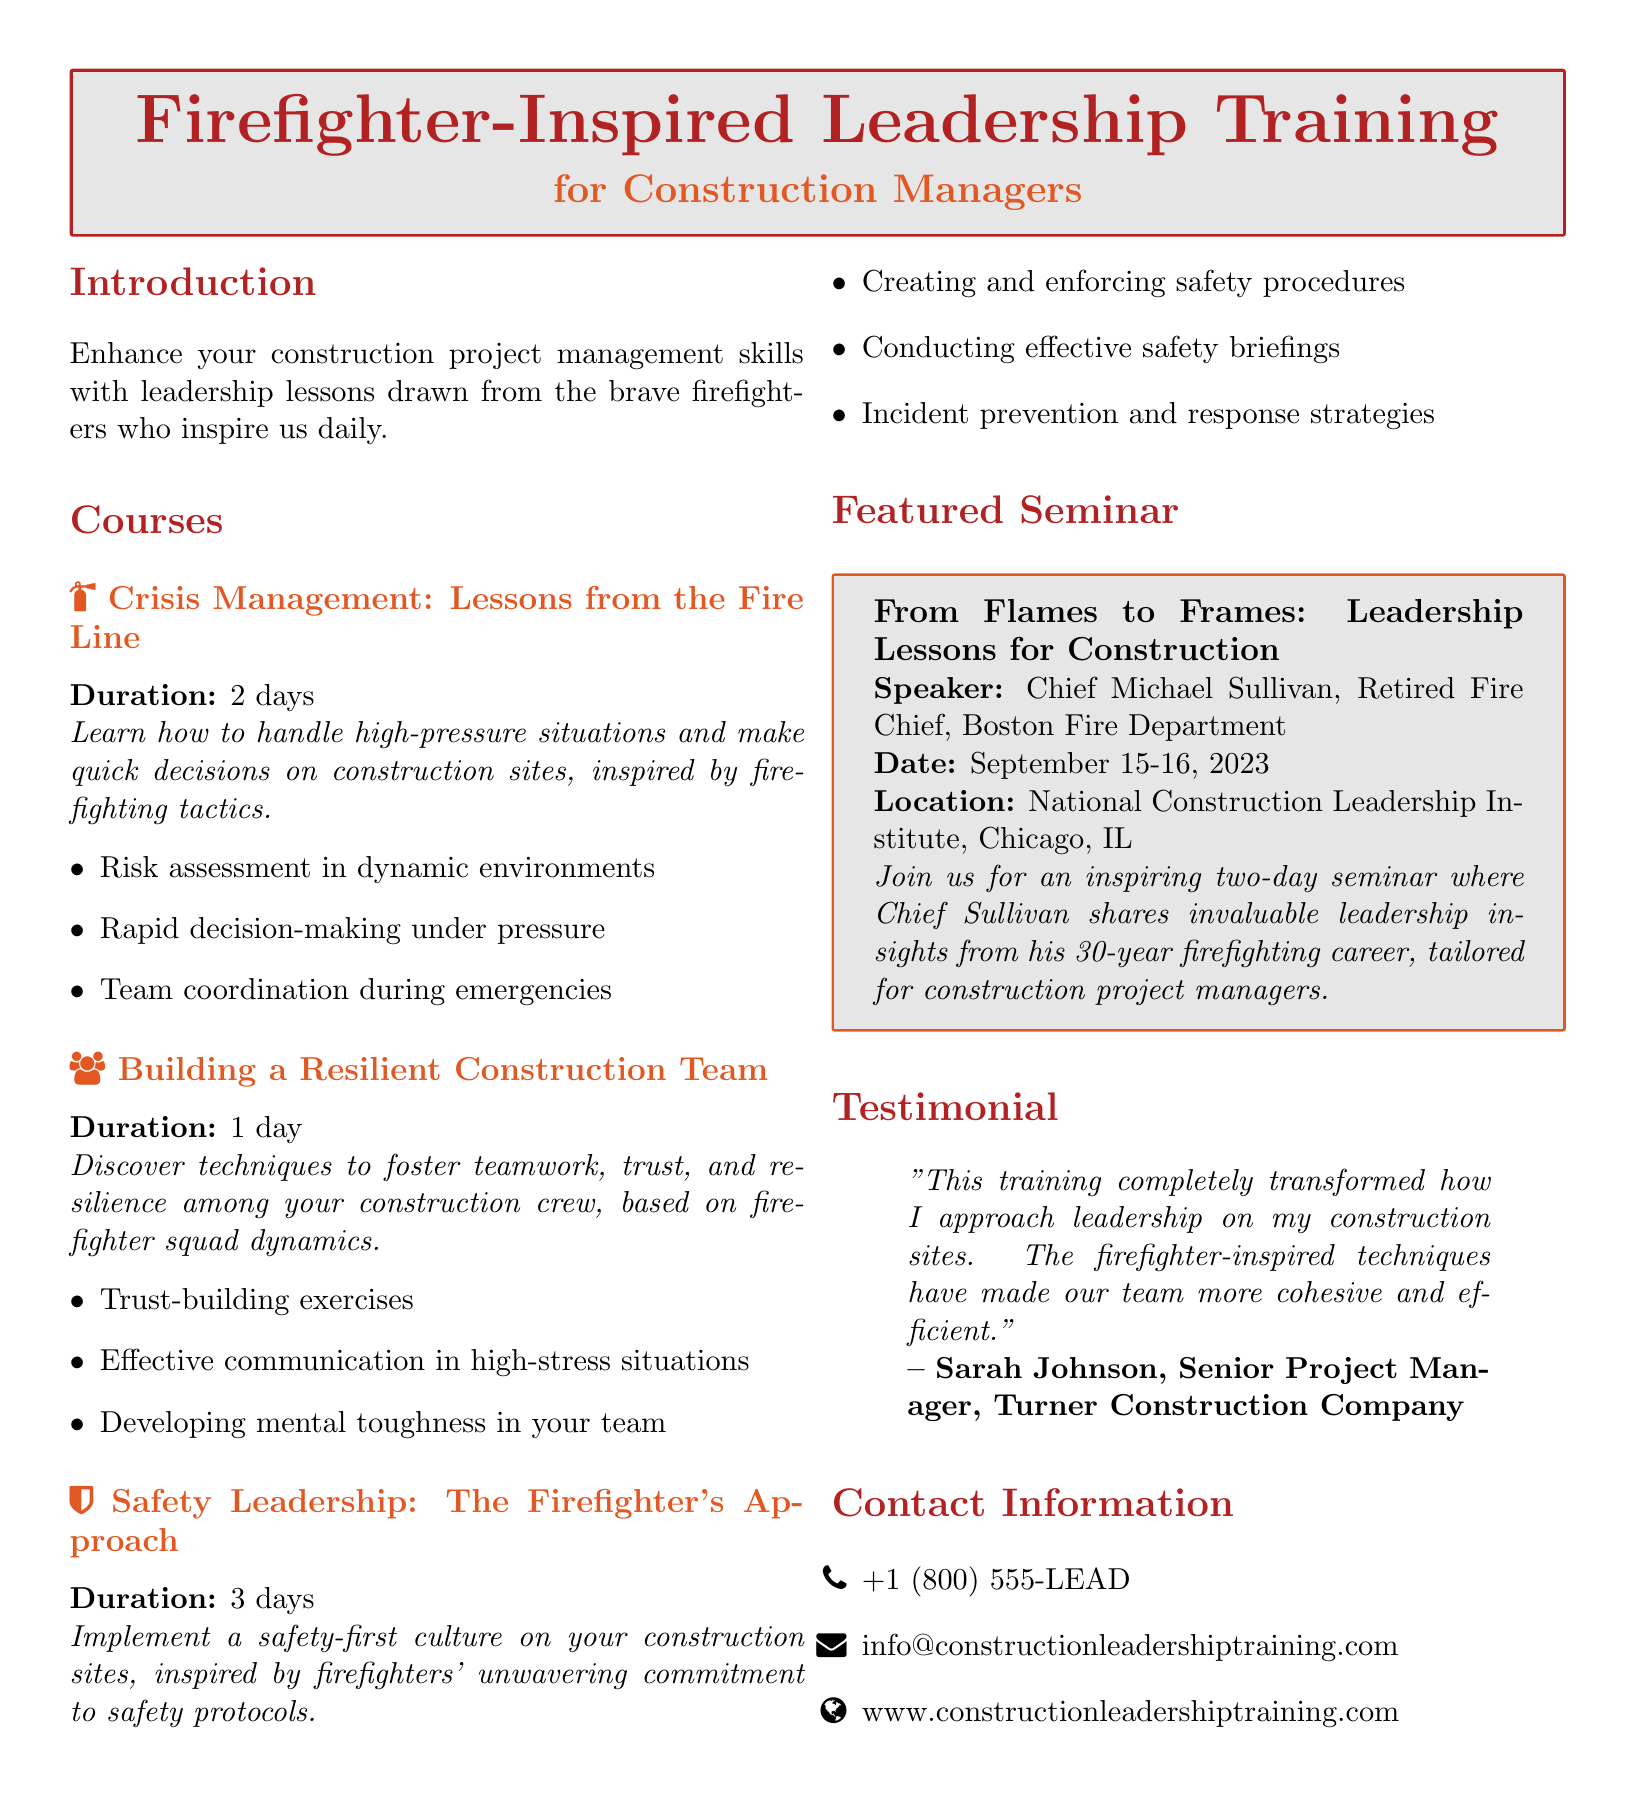What is the title of the seminar? The document provides the seminar title as "From Flames to Frames: Leadership Lessons for Construction."
Answer: From Flames to Frames: Leadership Lessons for Construction Who is the speaker for the featured seminar? The document mentions Chief Michael Sullivan as the speaker for the seminar.
Answer: Chief Michael Sullivan What is the duration of the "Crisis Management" course? The duration for the "Crisis Management" course is listed as 2 days in the document.
Answer: 2 days What is the date of the featured seminar? The document states the seminar date is September 15-16, 2023.
Answer: September 15-16, 2023 What is one key topic covered in the "Building a Resilient Construction Team" course? The course includes topics such as trust-building exercises, which is specified in the document.
Answer: Trust-building exercises How long is the "Safety Leadership" course? According to the document, the duration of the "Safety Leadership" course is 3 days.
Answer: 3 days What is the location of the featured seminar? The document indicates that the seminar will be held at the National Construction Leadership Institute, Chicago, IL.
Answer: National Construction Leadership Institute, Chicago, IL What is the primary focus of the courses offered? The document highlights that the courses offer leadership lessons drawn from the experiences of firefighters.
Answer: Leadership lessons drawn from firefighters What is one benefit of the training mentioned in the testimonial? The testimonial notes that the training transformed the approach to leadership on construction sites.
Answer: Transformed the approach to leadership 